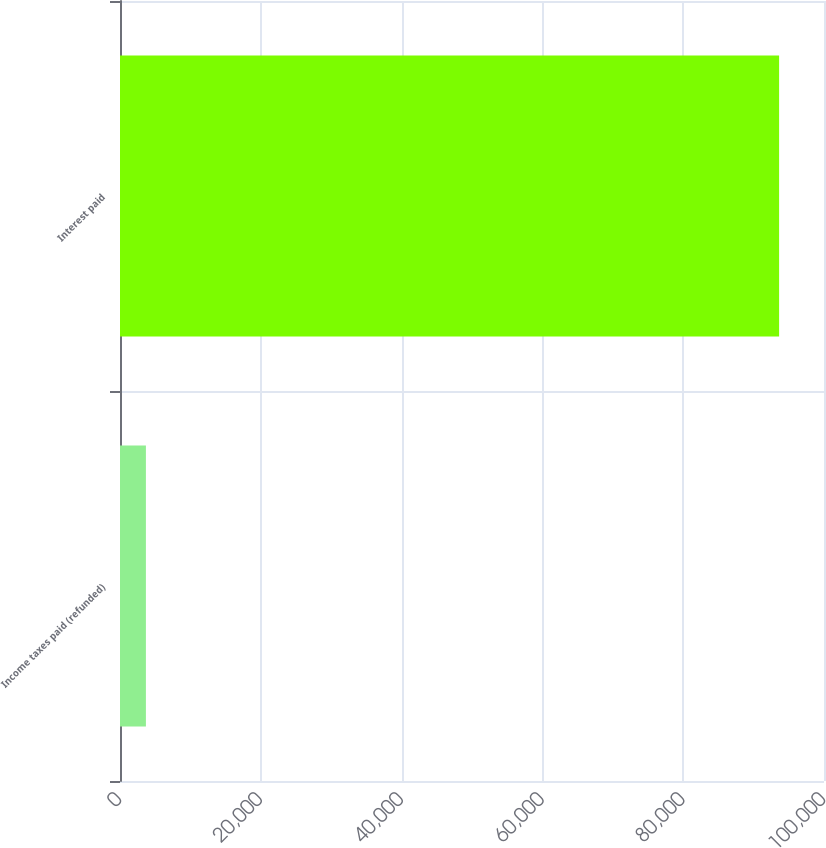Convert chart to OTSL. <chart><loc_0><loc_0><loc_500><loc_500><bar_chart><fcel>Income taxes paid (refunded)<fcel>Interest paid<nl><fcel>3680<fcel>93624<nl></chart> 